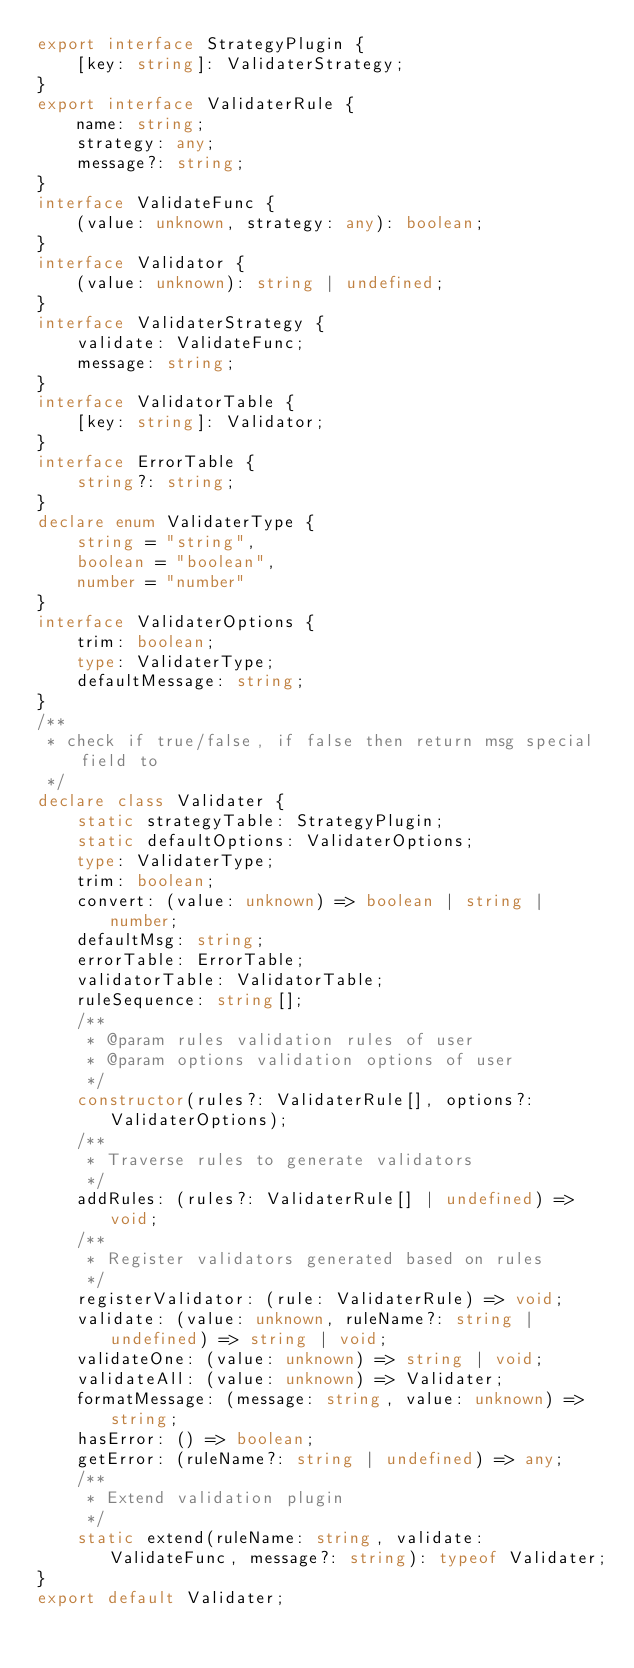<code> <loc_0><loc_0><loc_500><loc_500><_TypeScript_>export interface StrategyPlugin {
    [key: string]: ValidaterStrategy;
}
export interface ValidaterRule {
    name: string;
    strategy: any;
    message?: string;
}
interface ValidateFunc {
    (value: unknown, strategy: any): boolean;
}
interface Validator {
    (value: unknown): string | undefined;
}
interface ValidaterStrategy {
    validate: ValidateFunc;
    message: string;
}
interface ValidatorTable {
    [key: string]: Validator;
}
interface ErrorTable {
    string?: string;
}
declare enum ValidaterType {
    string = "string",
    boolean = "boolean",
    number = "number"
}
interface ValidaterOptions {
    trim: boolean;
    type: ValidaterType;
    defaultMessage: string;
}
/**
 * check if true/false, if false then return msg special field to
 */
declare class Validater {
    static strategyTable: StrategyPlugin;
    static defaultOptions: ValidaterOptions;
    type: ValidaterType;
    trim: boolean;
    convert: (value: unknown) => boolean | string | number;
    defaultMsg: string;
    errorTable: ErrorTable;
    validatorTable: ValidatorTable;
    ruleSequence: string[];
    /**
     * @param rules validation rules of user
     * @param options validation options of user
     */
    constructor(rules?: ValidaterRule[], options?: ValidaterOptions);
    /**
     * Traverse rules to generate validators
     */
    addRules: (rules?: ValidaterRule[] | undefined) => void;
    /**
     * Register validators generated based on rules
     */
    registerValidator: (rule: ValidaterRule) => void;
    validate: (value: unknown, ruleName?: string | undefined) => string | void;
    validateOne: (value: unknown) => string | void;
    validateAll: (value: unknown) => Validater;
    formatMessage: (message: string, value: unknown) => string;
    hasError: () => boolean;
    getError: (ruleName?: string | undefined) => any;
    /**
     * Extend validation plugin
     */
    static extend(ruleName: string, validate: ValidateFunc, message?: string): typeof Validater;
}
export default Validater;
</code> 